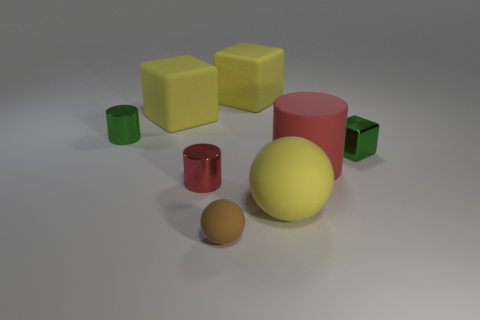There is a tiny metal cylinder to the right of the green thing on the left side of the tiny metallic cube; how many large red objects are in front of it?
Your answer should be very brief. 0. What size is the other cylinder that is the same color as the large matte cylinder?
Offer a terse response. Small. Are there any small blocks made of the same material as the big red cylinder?
Offer a terse response. No. Is the brown ball made of the same material as the large sphere?
Keep it short and to the point. Yes. There is a metallic object that is on the right side of the small red shiny cylinder; how many yellow things are in front of it?
Provide a short and direct response. 1. What number of brown objects are large rubber cylinders or shiny objects?
Ensure brevity in your answer.  0. There is a green shiny object to the right of the green shiny object on the left side of the big yellow matte object that is in front of the tiny green cylinder; what is its shape?
Ensure brevity in your answer.  Cube. There is a rubber object that is the same size as the green cube; what is its color?
Ensure brevity in your answer.  Brown. How many other objects have the same shape as the big red object?
Make the answer very short. 2. There is a brown thing; is it the same size as the metal object that is behind the green metallic block?
Keep it short and to the point. Yes. 